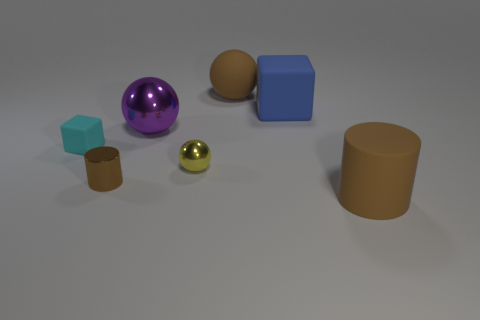Are there any metallic balls that have the same size as the cyan cube?
Keep it short and to the point. Yes. Do the brown cylinder that is behind the big matte cylinder and the small cyan thing have the same material?
Offer a very short reply. No. Is the number of blue rubber cubes that are to the right of the matte cylinder the same as the number of metal cylinders that are right of the small cylinder?
Your response must be concise. Yes. There is a brown object that is left of the blue matte object and in front of the cyan cube; what is its shape?
Keep it short and to the point. Cylinder. There is a brown rubber sphere; what number of big blue cubes are behind it?
Offer a very short reply. 0. What number of other objects are there of the same shape as the yellow shiny thing?
Give a very brief answer. 2. Is the number of large brown things less than the number of big purple rubber blocks?
Your response must be concise. No. How big is the object that is both in front of the cyan rubber object and right of the tiny sphere?
Ensure brevity in your answer.  Large. There is a brown rubber thing that is behind the brown thing that is in front of the tiny cylinder in front of the purple metallic thing; how big is it?
Your answer should be compact. Large. The yellow metal object is what size?
Make the answer very short. Small. 